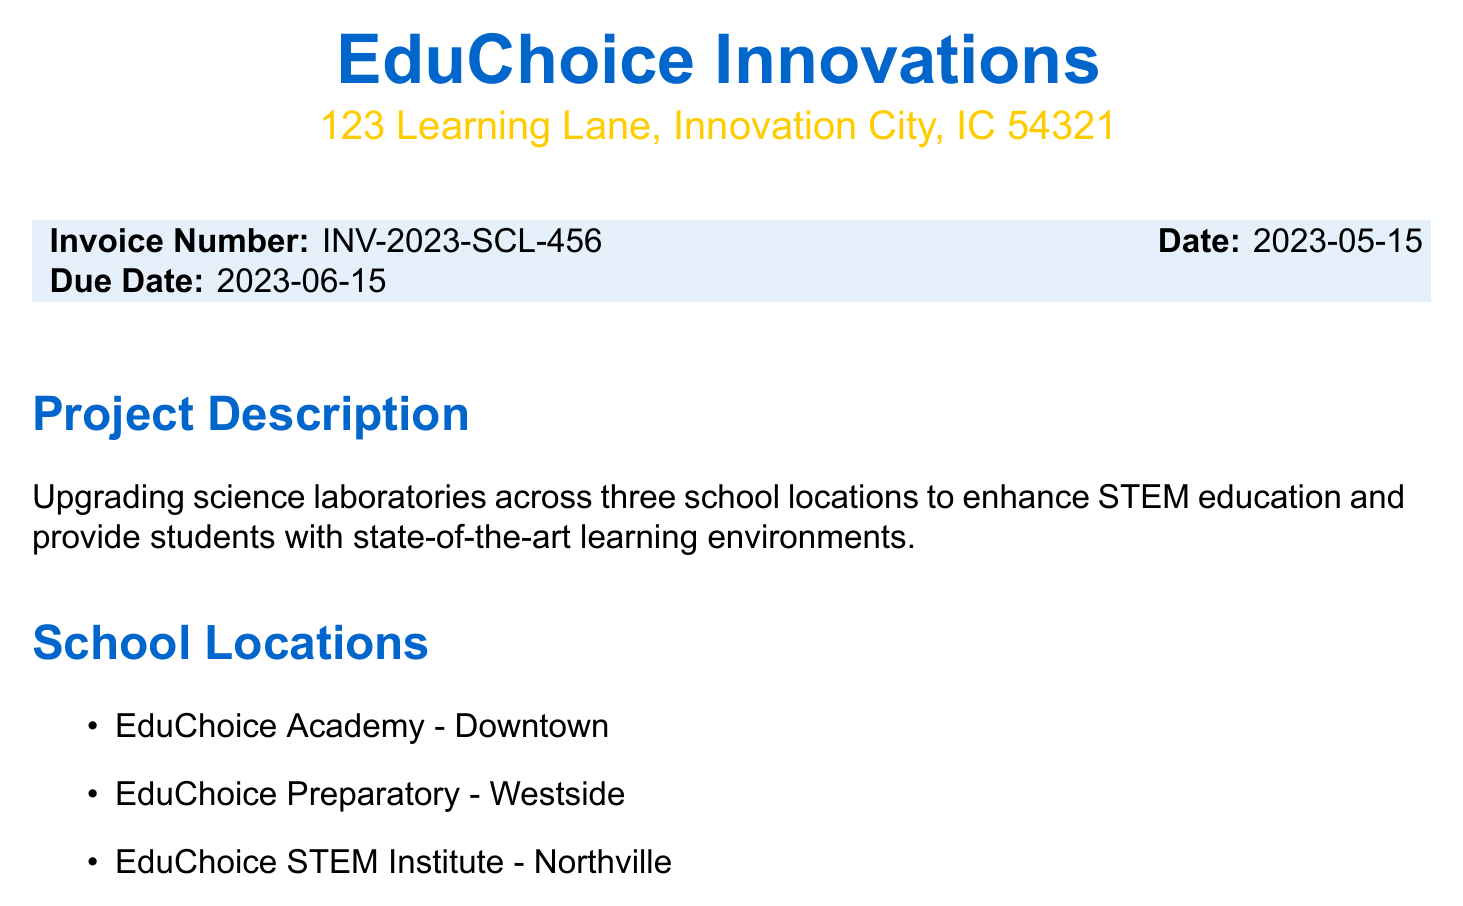What is the invoice number? The invoice number is a unique identifier for the transaction, which is stated in the document as INV-2023-SCL-456.
Answer: INV-2023-SCL-456 What is the total amount due? The total amount due is the final figure in the invoice, combining costs, taxes, and other charges, listed as $479,510.28.
Answer: $479,510.28 What is the tax rate applied to this invoice? The tax rate is indicated specifically in the invoice, noted as 8%.
Answer: 8% How many locations are involved in this project? The document lists three school locations that are part of the project upgrade.
Answer: Three What is the subtotal before tax? The subtotal reflects the total of all costs before tax is applied, given as $443,991.00.
Answer: $443,991.00 What is the payment term for this invoice? The payment terms are specified towards the end of the document, indicating the payment due time frame.
Answer: Net 30 What type of upgrade is being conducted? The project description indicates that the upgrade focuses on enhancing science laboratories specifically.
Answer: Enhancing science laboratories How many Vernier LabQuest 3 Data Collection Devices are being purchased? The quantity of Vernier LabQuest 3 Data Collection Devices is directly stated in the line items section of the invoice.
Answer: 45 What is included as part of the labor costs? The labor costs include various services, such as electrical upgrades, plumbing installation, and equipment calibration mentioned in the document.
Answer: Electrical upgrades, plumbing installation, equipment calibration 